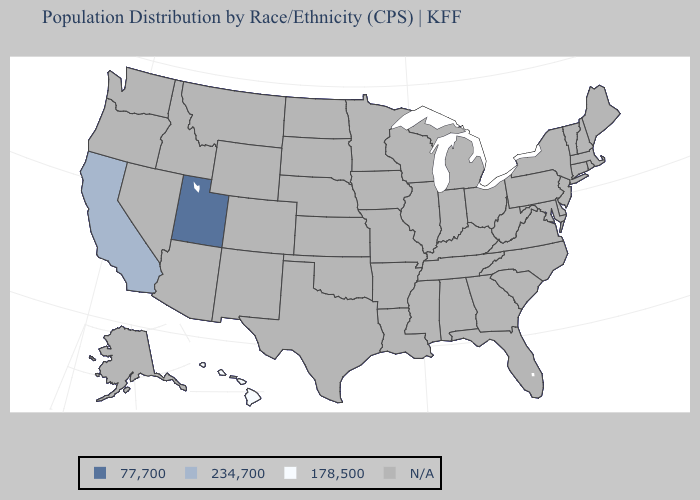What is the value of New Mexico?
Concise answer only. N/A. Name the states that have a value in the range 234,700?
Give a very brief answer. California. What is the lowest value in the West?
Keep it brief. 178,500. Name the states that have a value in the range 77,700?
Write a very short answer. Utah. What is the value of Vermont?
Quick response, please. N/A. Name the states that have a value in the range 178,500?
Give a very brief answer. Hawaii. What is the value of Alaska?
Be succinct. N/A. Name the states that have a value in the range 234,700?
Concise answer only. California. Does Utah have the highest value in the USA?
Be succinct. Yes. Which states have the highest value in the USA?
Quick response, please. Utah. Name the states that have a value in the range 77,700?
Write a very short answer. Utah. What is the value of Arkansas?
Give a very brief answer. N/A. 